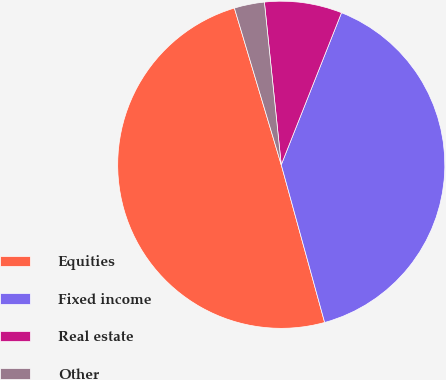Convert chart to OTSL. <chart><loc_0><loc_0><loc_500><loc_500><pie_chart><fcel>Equities<fcel>Fixed income<fcel>Real estate<fcel>Other<nl><fcel>49.65%<fcel>39.72%<fcel>7.65%<fcel>2.98%<nl></chart> 